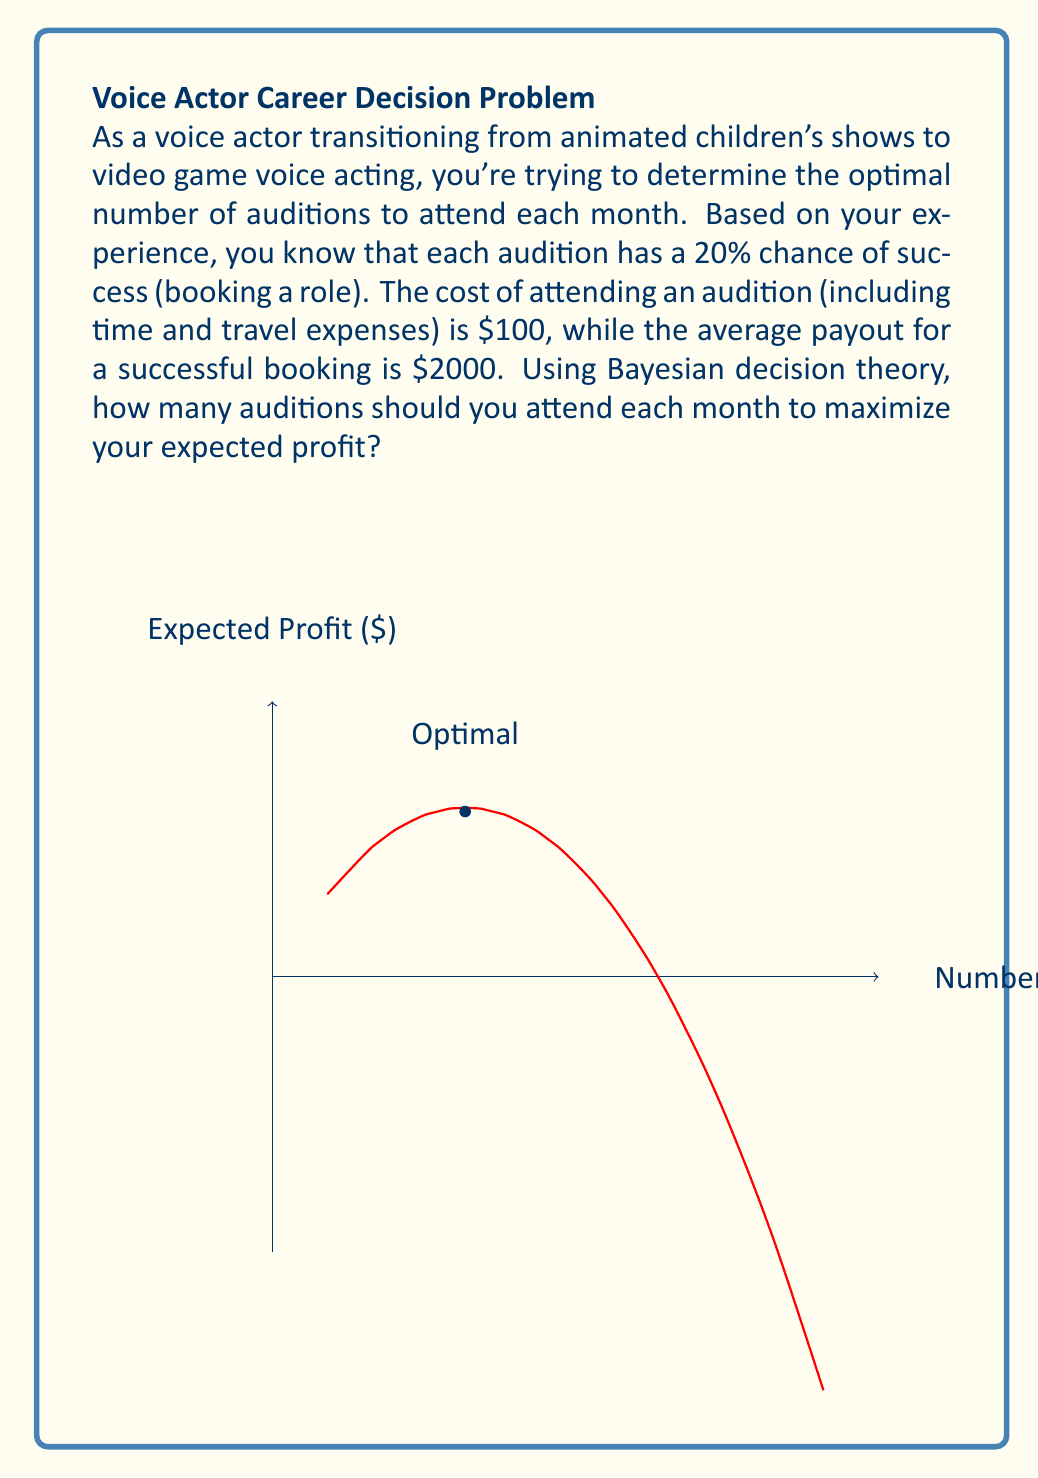Help me with this question. Let's approach this problem using Bayesian decision theory:

1) Define variables:
   $n$ = number of auditions
   $p$ = probability of success (0.2)
   $c$ = cost per audition ($100)
   $r$ = reward for successful booking ($2000)

2) Expected number of successes:
   $E(successes) = np$

3) Expected revenue:
   $E(revenue) = npr$

4) Total cost:
   $Cost = nc$

5) Expected profit:
   $E(profit) = E(revenue) - Cost$
   $E(profit) = npr - nc$

6) Substitute known values:
   $E(profit) = n(0.2 * 2000) - n(100)$
   $E(profit) = 400n - 100n$
   $E(profit) = 300n$

7) To find the optimal number of auditions, we need to consider the law of diminishing returns. The expected profit increases linearly with $n$, but in reality, there's a limit to how many auditions you can attend and how many roles you can take.

8) Let's introduce a constraint: assume you can realistically handle up to 5 roles per month. The probability of getting more than 5 roles becomes our new limiting factor.

9) Calculate the probability of getting more than 5 roles using the binomial distribution:
   $P(X > 5) = 1 - P(X \leq 5) = 1 - \sum_{k=0}^5 \binom{n}{k}p^k(1-p)^{n-k}$

10) We want to find $n$ where this probability becomes significant (e.g., > 0.1):
    For $n = 10$: $P(X > 5) \approx 0.015$
    For $n = 20$: $P(X > 5) \approx 0.2$
    For $n = 30$: $P(X > 5) \approx 0.5$

11) Based on this, a reasonable optimal number of auditions would be around 20-25 per month.

12) Expected profit at 20 auditions:
    $E(profit) = 300 * 20 = $6000$
Answer: 20-25 auditions per month 